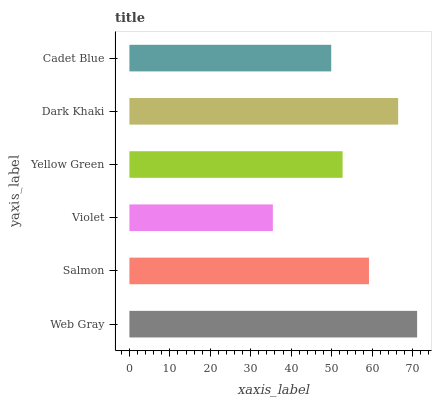Is Violet the minimum?
Answer yes or no. Yes. Is Web Gray the maximum?
Answer yes or no. Yes. Is Salmon the minimum?
Answer yes or no. No. Is Salmon the maximum?
Answer yes or no. No. Is Web Gray greater than Salmon?
Answer yes or no. Yes. Is Salmon less than Web Gray?
Answer yes or no. Yes. Is Salmon greater than Web Gray?
Answer yes or no. No. Is Web Gray less than Salmon?
Answer yes or no. No. Is Salmon the high median?
Answer yes or no. Yes. Is Yellow Green the low median?
Answer yes or no. Yes. Is Web Gray the high median?
Answer yes or no. No. Is Web Gray the low median?
Answer yes or no. No. 